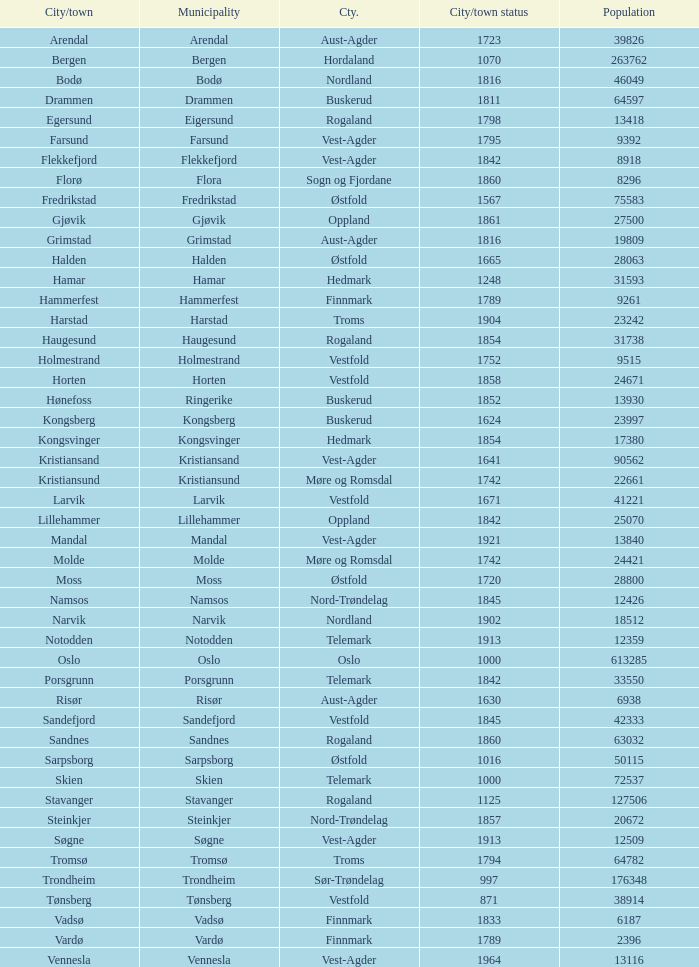What are the urban areas situated in the municipality of horten? Horten. 